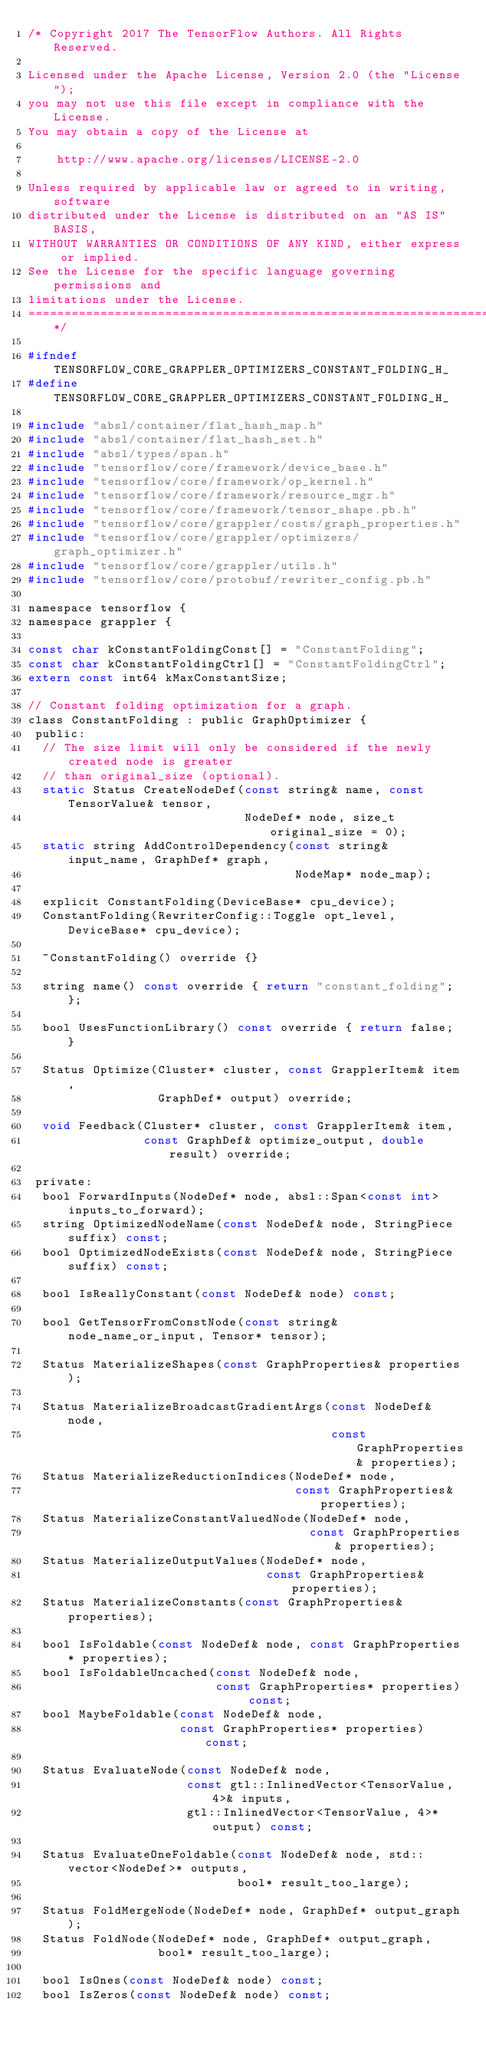Convert code to text. <code><loc_0><loc_0><loc_500><loc_500><_C_>/* Copyright 2017 The TensorFlow Authors. All Rights Reserved.

Licensed under the Apache License, Version 2.0 (the "License");
you may not use this file except in compliance with the License.
You may obtain a copy of the License at

    http://www.apache.org/licenses/LICENSE-2.0

Unless required by applicable law or agreed to in writing, software
distributed under the License is distributed on an "AS IS" BASIS,
WITHOUT WARRANTIES OR CONDITIONS OF ANY KIND, either express or implied.
See the License for the specific language governing permissions and
limitations under the License.
==============================================================================*/

#ifndef TENSORFLOW_CORE_GRAPPLER_OPTIMIZERS_CONSTANT_FOLDING_H_
#define TENSORFLOW_CORE_GRAPPLER_OPTIMIZERS_CONSTANT_FOLDING_H_

#include "absl/container/flat_hash_map.h"
#include "absl/container/flat_hash_set.h"
#include "absl/types/span.h"
#include "tensorflow/core/framework/device_base.h"
#include "tensorflow/core/framework/op_kernel.h"
#include "tensorflow/core/framework/resource_mgr.h"
#include "tensorflow/core/framework/tensor_shape.pb.h"
#include "tensorflow/core/grappler/costs/graph_properties.h"
#include "tensorflow/core/grappler/optimizers/graph_optimizer.h"
#include "tensorflow/core/grappler/utils.h"
#include "tensorflow/core/protobuf/rewriter_config.pb.h"

namespace tensorflow {
namespace grappler {

const char kConstantFoldingConst[] = "ConstantFolding";
const char kConstantFoldingCtrl[] = "ConstantFoldingCtrl";
extern const int64 kMaxConstantSize;

// Constant folding optimization for a graph.
class ConstantFolding : public GraphOptimizer {
 public:
  // The size limit will only be considered if the newly created node is greater
  // than original_size (optional).
  static Status CreateNodeDef(const string& name, const TensorValue& tensor,
                              NodeDef* node, size_t original_size = 0);
  static string AddControlDependency(const string& input_name, GraphDef* graph,
                                     NodeMap* node_map);

  explicit ConstantFolding(DeviceBase* cpu_device);
  ConstantFolding(RewriterConfig::Toggle opt_level, DeviceBase* cpu_device);

  ~ConstantFolding() override {}

  string name() const override { return "constant_folding"; };

  bool UsesFunctionLibrary() const override { return false; }

  Status Optimize(Cluster* cluster, const GrapplerItem& item,
                  GraphDef* output) override;

  void Feedback(Cluster* cluster, const GrapplerItem& item,
                const GraphDef& optimize_output, double result) override;

 private:
  bool ForwardInputs(NodeDef* node, absl::Span<const int> inputs_to_forward);
  string OptimizedNodeName(const NodeDef& node, StringPiece suffix) const;
  bool OptimizedNodeExists(const NodeDef& node, StringPiece suffix) const;

  bool IsReallyConstant(const NodeDef& node) const;

  bool GetTensorFromConstNode(const string& node_name_or_input, Tensor* tensor);

  Status MaterializeShapes(const GraphProperties& properties);

  Status MaterializeBroadcastGradientArgs(const NodeDef& node,
                                          const GraphProperties& properties);
  Status MaterializeReductionIndices(NodeDef* node,
                                     const GraphProperties& properties);
  Status MaterializeConstantValuedNode(NodeDef* node,
                                       const GraphProperties& properties);
  Status MaterializeOutputValues(NodeDef* node,
                                 const GraphProperties& properties);
  Status MaterializeConstants(const GraphProperties& properties);

  bool IsFoldable(const NodeDef& node, const GraphProperties* properties);
  bool IsFoldableUncached(const NodeDef& node,
                          const GraphProperties* properties) const;
  bool MaybeFoldable(const NodeDef& node,
                     const GraphProperties* properties) const;

  Status EvaluateNode(const NodeDef& node,
                      const gtl::InlinedVector<TensorValue, 4>& inputs,
                      gtl::InlinedVector<TensorValue, 4>* output) const;

  Status EvaluateOneFoldable(const NodeDef& node, std::vector<NodeDef>* outputs,
                             bool* result_too_large);

  Status FoldMergeNode(NodeDef* node, GraphDef* output_graph);
  Status FoldNode(NodeDef* node, GraphDef* output_graph,
                  bool* result_too_large);

  bool IsOnes(const NodeDef& node) const;
  bool IsZeros(const NodeDef& node) const;</code> 